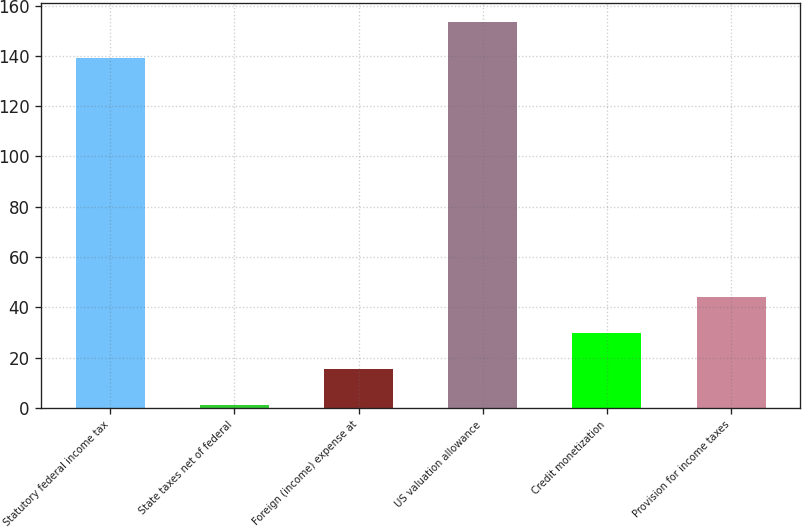Convert chart to OTSL. <chart><loc_0><loc_0><loc_500><loc_500><bar_chart><fcel>Statutory federal income tax<fcel>State taxes net of federal<fcel>Foreign (income) expense at<fcel>US valuation allowance<fcel>Credit monetization<fcel>Provision for income taxes<nl><fcel>139<fcel>1<fcel>15.3<fcel>153.3<fcel>29.6<fcel>43.9<nl></chart> 